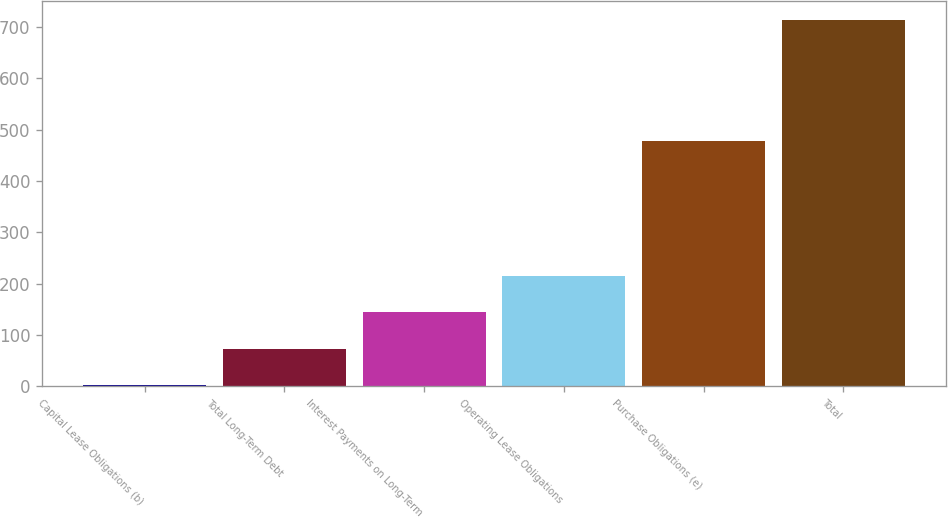Convert chart. <chart><loc_0><loc_0><loc_500><loc_500><bar_chart><fcel>Capital Lease Obligations (b)<fcel>Total Long-Term Debt<fcel>Interest Payments on Long-Term<fcel>Operating Lease Obligations<fcel>Purchase Obligations (e)<fcel>Total<nl><fcel>1.3<fcel>72.61<fcel>143.92<fcel>215.23<fcel>477.7<fcel>714.4<nl></chart> 